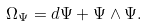Convert formula to latex. <formula><loc_0><loc_0><loc_500><loc_500>\Omega _ { \Psi } = d \Psi + \Psi \wedge \Psi .</formula> 